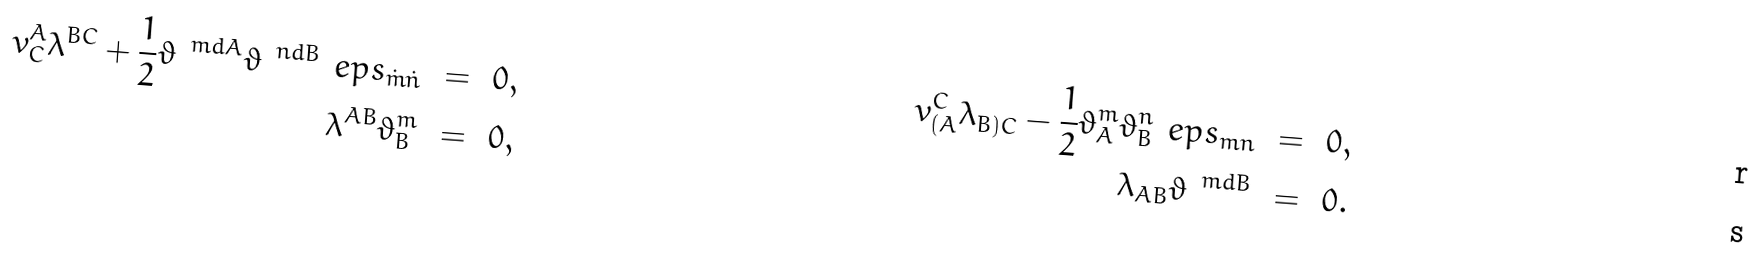Convert formula to latex. <formula><loc_0><loc_0><loc_500><loc_500>v ^ { A } _ { C } \lambda ^ { B C } + \frac { 1 } { 2 } \vartheta ^ { \ m d A } \vartheta ^ { \ n d B } \ e p s _ { \dot { m } \dot { n } } \ & = \ 0 , & v _ { ( A } ^ { C } \lambda _ { B ) C } - \frac { 1 } { 2 } \vartheta _ { A } ^ { m } \vartheta _ { B } ^ { n } \ e p s _ { m n } \ & = \ 0 , \\ \lambda ^ { A B } \vartheta ^ { m } _ { B } \ & = \ 0 , & \lambda _ { A B } \vartheta ^ { \ m d B } \ & = \ 0 .</formula> 